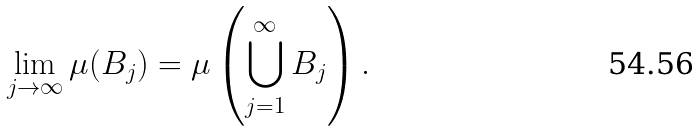<formula> <loc_0><loc_0><loc_500><loc_500>\lim _ { j \to \infty } \mu ( B _ { j } ) = \mu \left ( \bigcup _ { j = 1 } ^ { \infty } B _ { j } \right ) .</formula> 